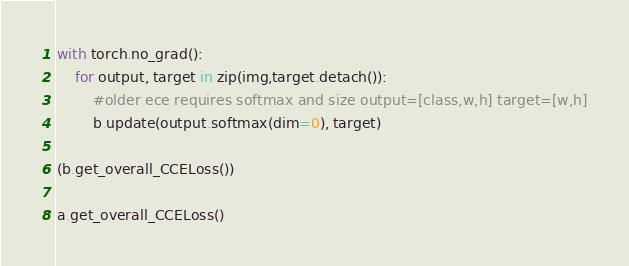Convert code to text. <code><loc_0><loc_0><loc_500><loc_500><_Python_>with torch.no_grad():
    for output, target in zip(img,target.detach()):
        #older ece requires softmax and size output=[class,w,h] target=[w,h]
        b.update(output.softmax(dim=0), target)

(b.get_overall_CCELoss())

a.get_overall_CCELoss()</code> 